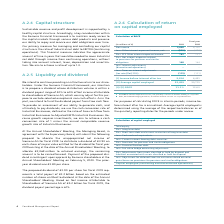According to Siemens Ag's financial document, How is the Average capital employed is determined ? using the average of the respective balances as of the quarterly reporting dates for the periods under review.. The document states: "annualized. Average capital employed is determined using the average of the respective balances as of the quarterly reporting dates for the periods un..." Also, What does Item Other interest expenses / income consist of? net primarily consists of interest relating to corporate debt, and related hedging activities, as well as interest income on corporate assets.. The document states: "1 Item Other interest expenses / income, net primarily consists of interest relating to corporate debt, and related hedging activities, as well as int..." Also, What is the income tax rate for 2019? According to the financial document, 30%. The relevant text states: "s: Taxes on interest adjustments (tax rate (flat) 30 %) (115) (121)..." Also, can you calculate: What is the average net income for the 2 years? To answer this question, I need to perform calculations using the financial data. The calculation is: (5,648 + 6,120) / 2, which equals 5884 (in millions). This is based on the information: "Net income 5,648 6,120 Net income 5,648 6,120..." The key data points involved are: 5,648, 6,120. Also, can you calculate: What is the increase / (decrease) in income tax from 2018 to 2019? To answer this question, I need to perform calculations using the financial data. The calculation is: -115 / -121 - 1, which equals -4.96 (percentage). This is based on the information: "nterest adjustments (tax rate (flat) 30 %) (115) (121) s on interest adjustments (tax rate (flat) 30 %) (115) (121)..." The key data points involved are: 115, 121. Also, can you calculate: What is the increase / (decrease) in Average capital employed from 2018 to 2019? Based on the calculation: 53,459 - 50,715, the result is 2744 (in millions). This is based on the information: "(II) Average capital employed 53,459 50,715 (II) Average capital employed 53,459 50,715..." The key data points involved are: 50,715, 53,459. 